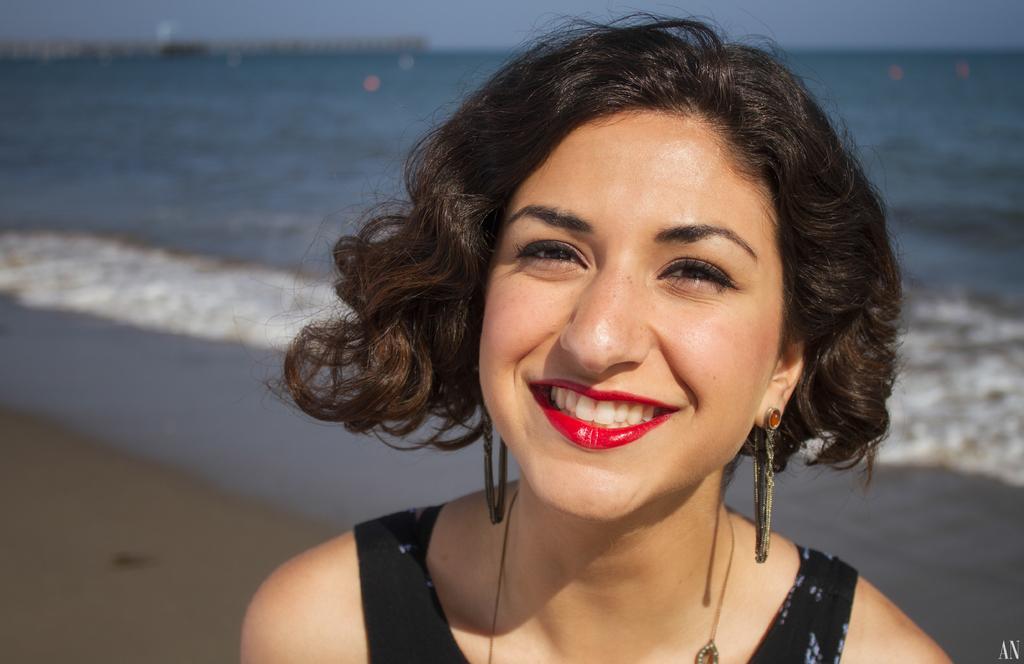Could you give a brief overview of what you see in this image? In this image I can see a woman wearing black colored dress and red color lipstick is smiling. In the background I can see the sand, the water and the sky. 